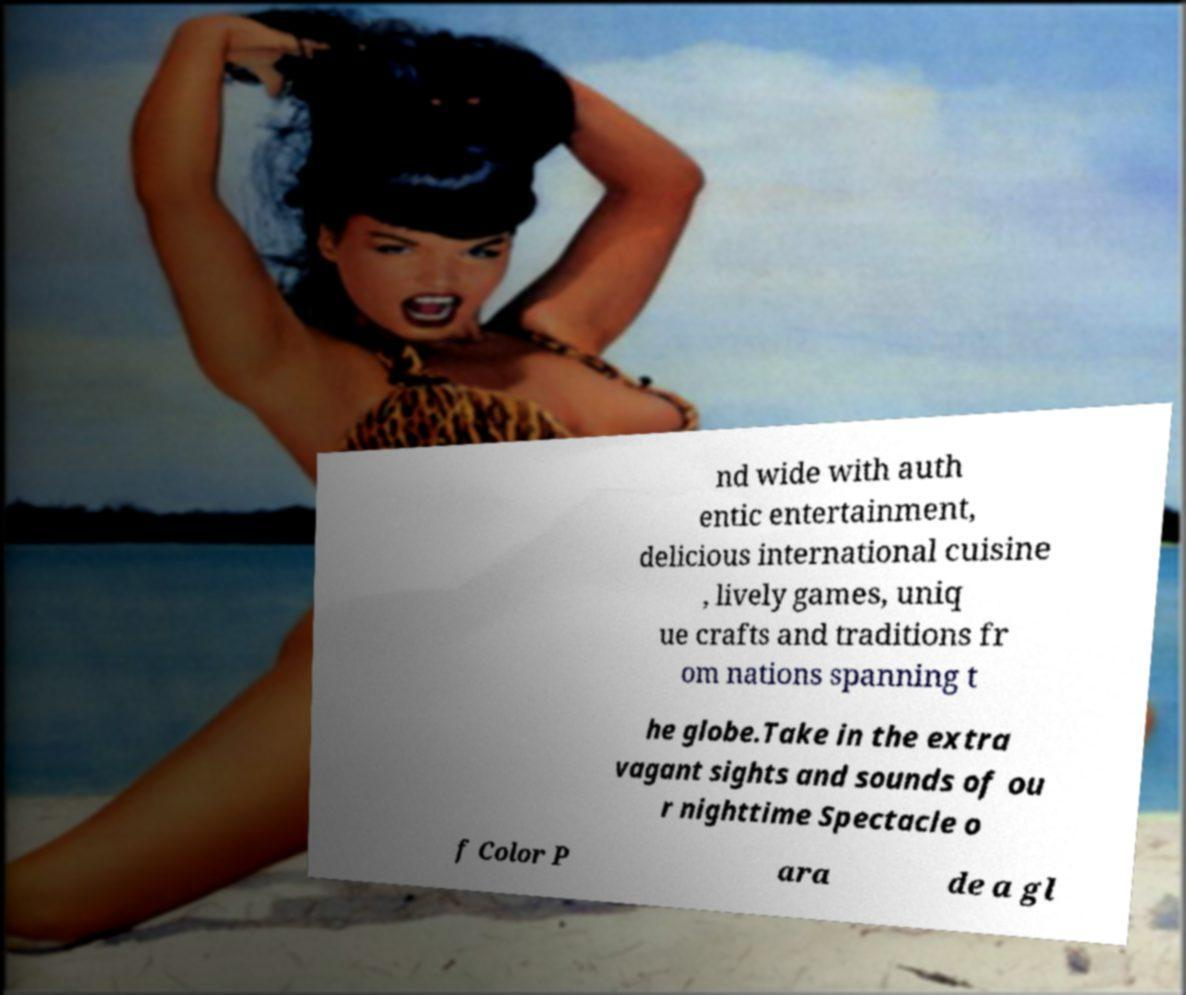What messages or text are displayed in this image? I need them in a readable, typed format. nd wide with auth entic entertainment, delicious international cuisine , lively games, uniq ue crafts and traditions fr om nations spanning t he globe.Take in the extra vagant sights and sounds of ou r nighttime Spectacle o f Color P ara de a gl 